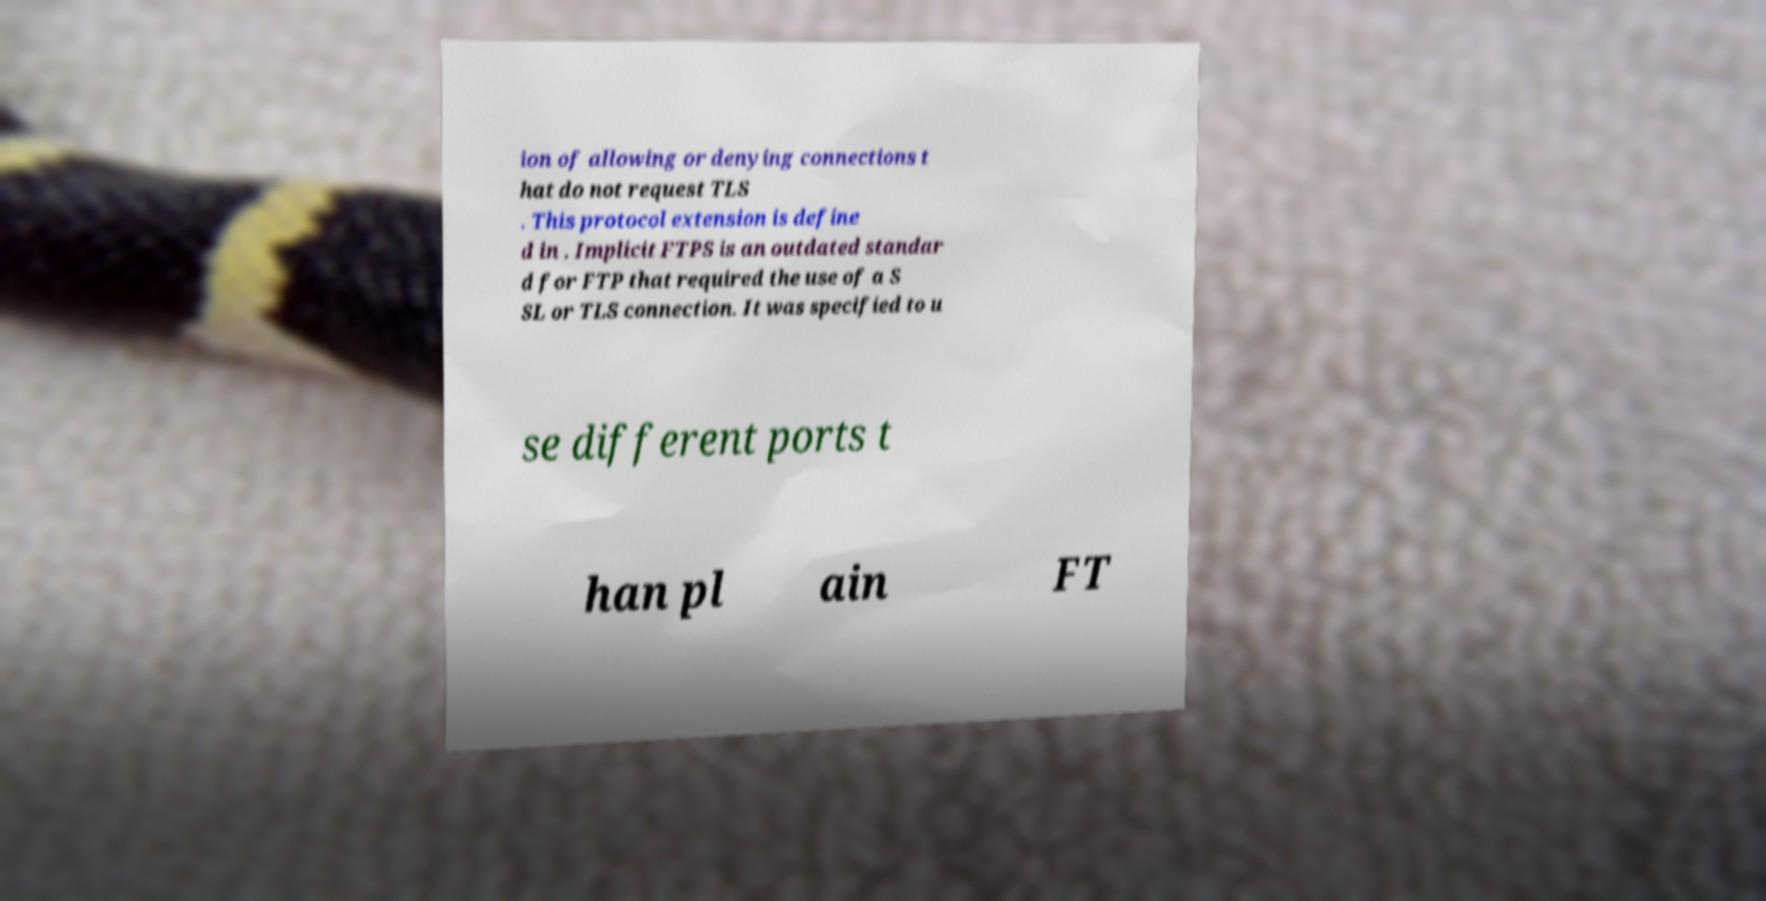I need the written content from this picture converted into text. Can you do that? ion of allowing or denying connections t hat do not request TLS . This protocol extension is define d in . Implicit FTPS is an outdated standar d for FTP that required the use of a S SL or TLS connection. It was specified to u se different ports t han pl ain FT 